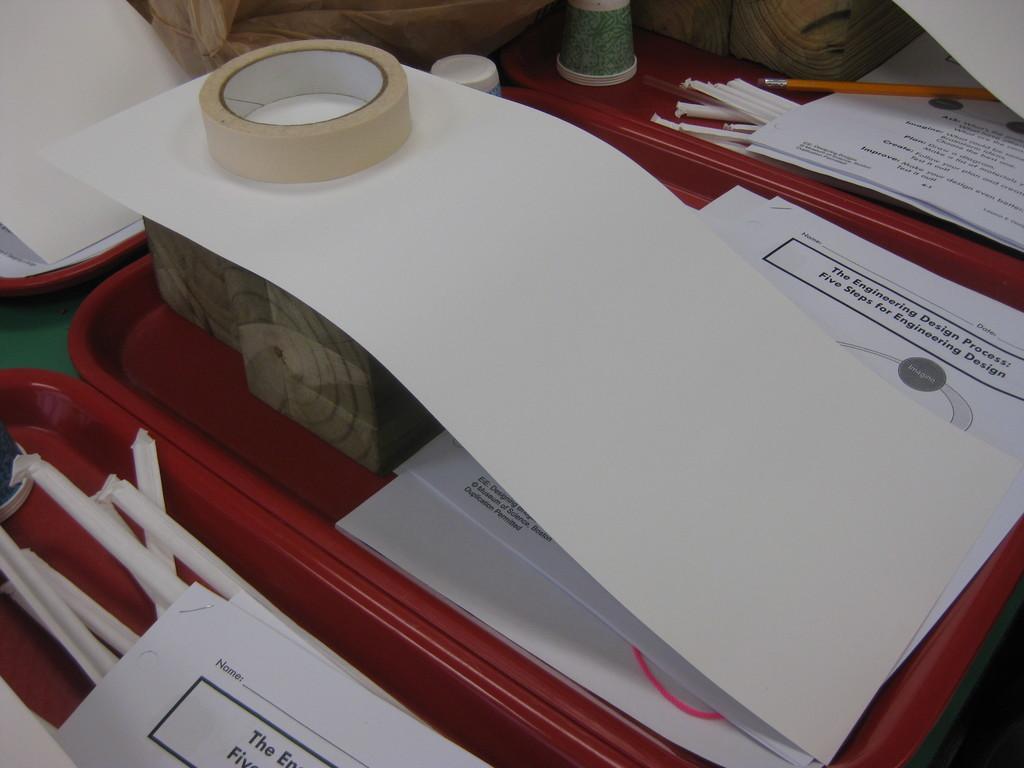Can you describe this image briefly? In this image we can see group of papers ,pencils ,cups ,tape and boxes are placed in several trays. In the background we can see wood blocks. 